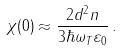<formula> <loc_0><loc_0><loc_500><loc_500>\chi ( 0 ) \approx \frac { 2 d ^ { 2 } n } { 3 \hbar { \omega } _ { T } \varepsilon _ { 0 } } \, .</formula> 